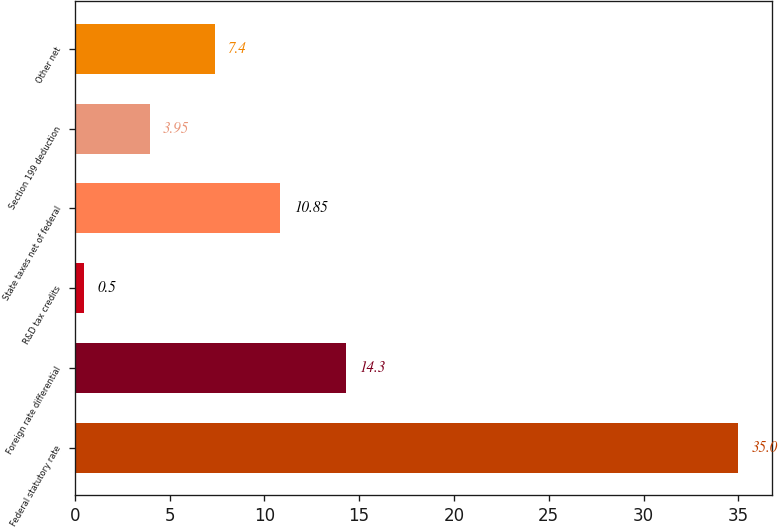<chart> <loc_0><loc_0><loc_500><loc_500><bar_chart><fcel>Federal statutory rate<fcel>Foreign rate differential<fcel>R&D tax credits<fcel>State taxes net of federal<fcel>Section 199 deduction<fcel>Other net<nl><fcel>35<fcel>14.3<fcel>0.5<fcel>10.85<fcel>3.95<fcel>7.4<nl></chart> 